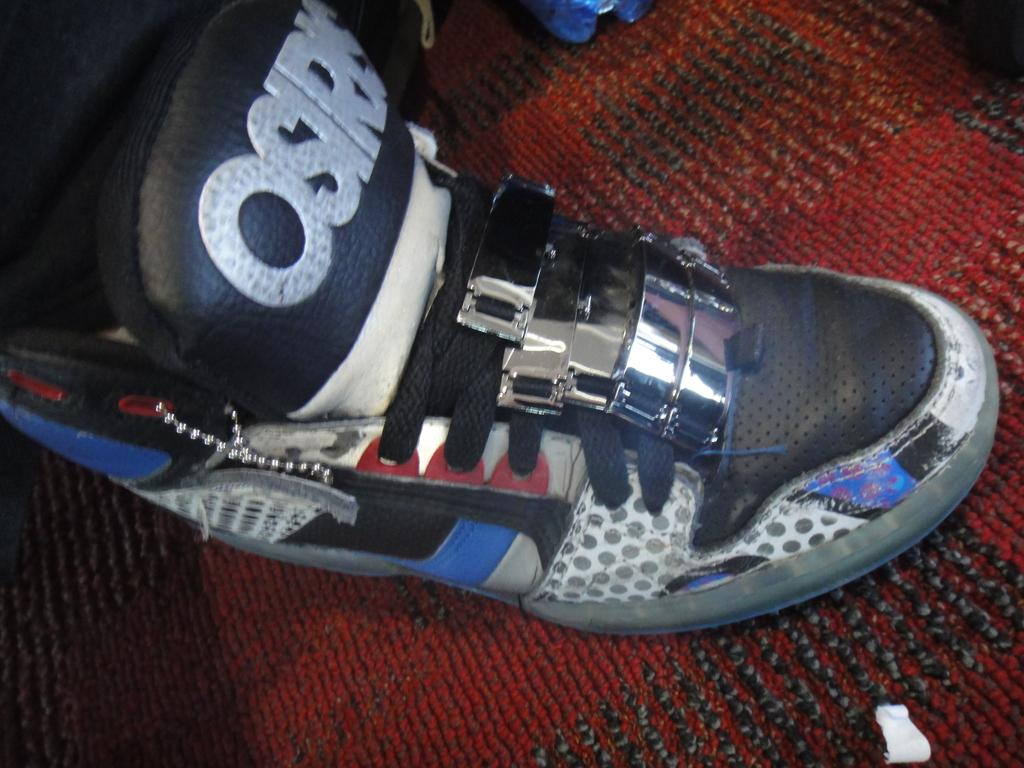<image>
Present a compact description of the photo's key features. A pair of white, black and blue Osiris shoes. 